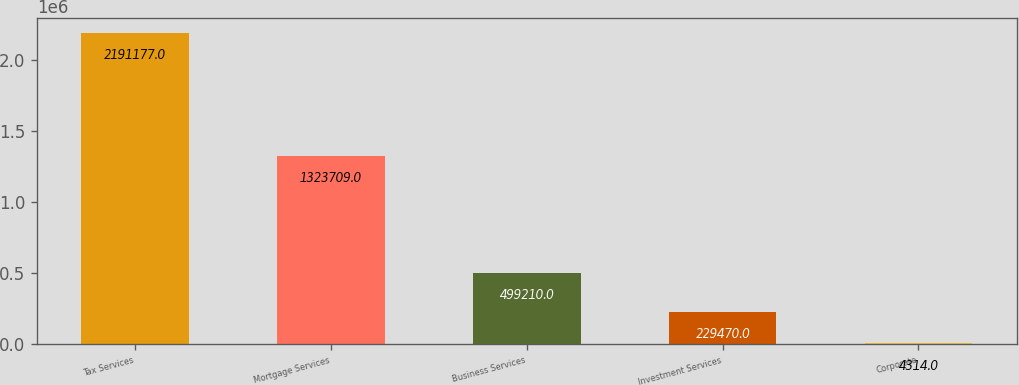<chart> <loc_0><loc_0><loc_500><loc_500><bar_chart><fcel>Tax Services<fcel>Mortgage Services<fcel>Business Services<fcel>Investment Services<fcel>Corporate<nl><fcel>2.19118e+06<fcel>1.32371e+06<fcel>499210<fcel>229470<fcel>4314<nl></chart> 